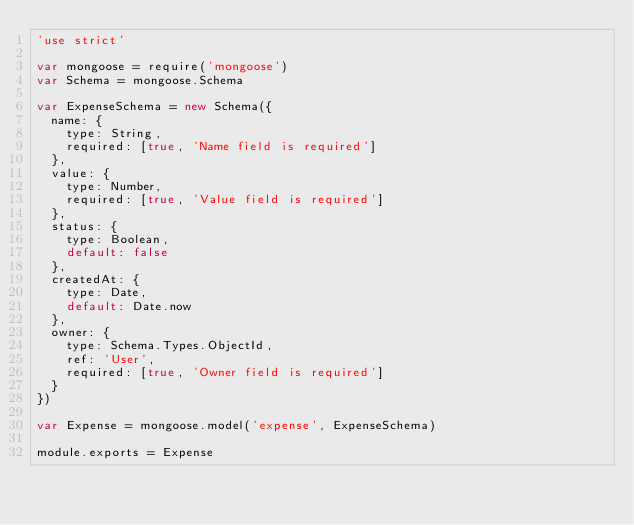Convert code to text. <code><loc_0><loc_0><loc_500><loc_500><_JavaScript_>'use strict'

var mongoose = require('mongoose')
var Schema = mongoose.Schema

var ExpenseSchema = new Schema({
  name: {
    type: String,
    required: [true, 'Name field is required']
  },
  value: {
    type: Number,
    required: [true, 'Value field is required']
  },
  status: {
    type: Boolean,
    default: false
  },
  createdAt: {
    type: Date,
    default: Date.now
  },
  owner: {
    type: Schema.Types.ObjectId,
    ref: 'User',
    required: [true, 'Owner field is required']
  }
})

var Expense = mongoose.model('expense', ExpenseSchema)

module.exports = Expense
</code> 